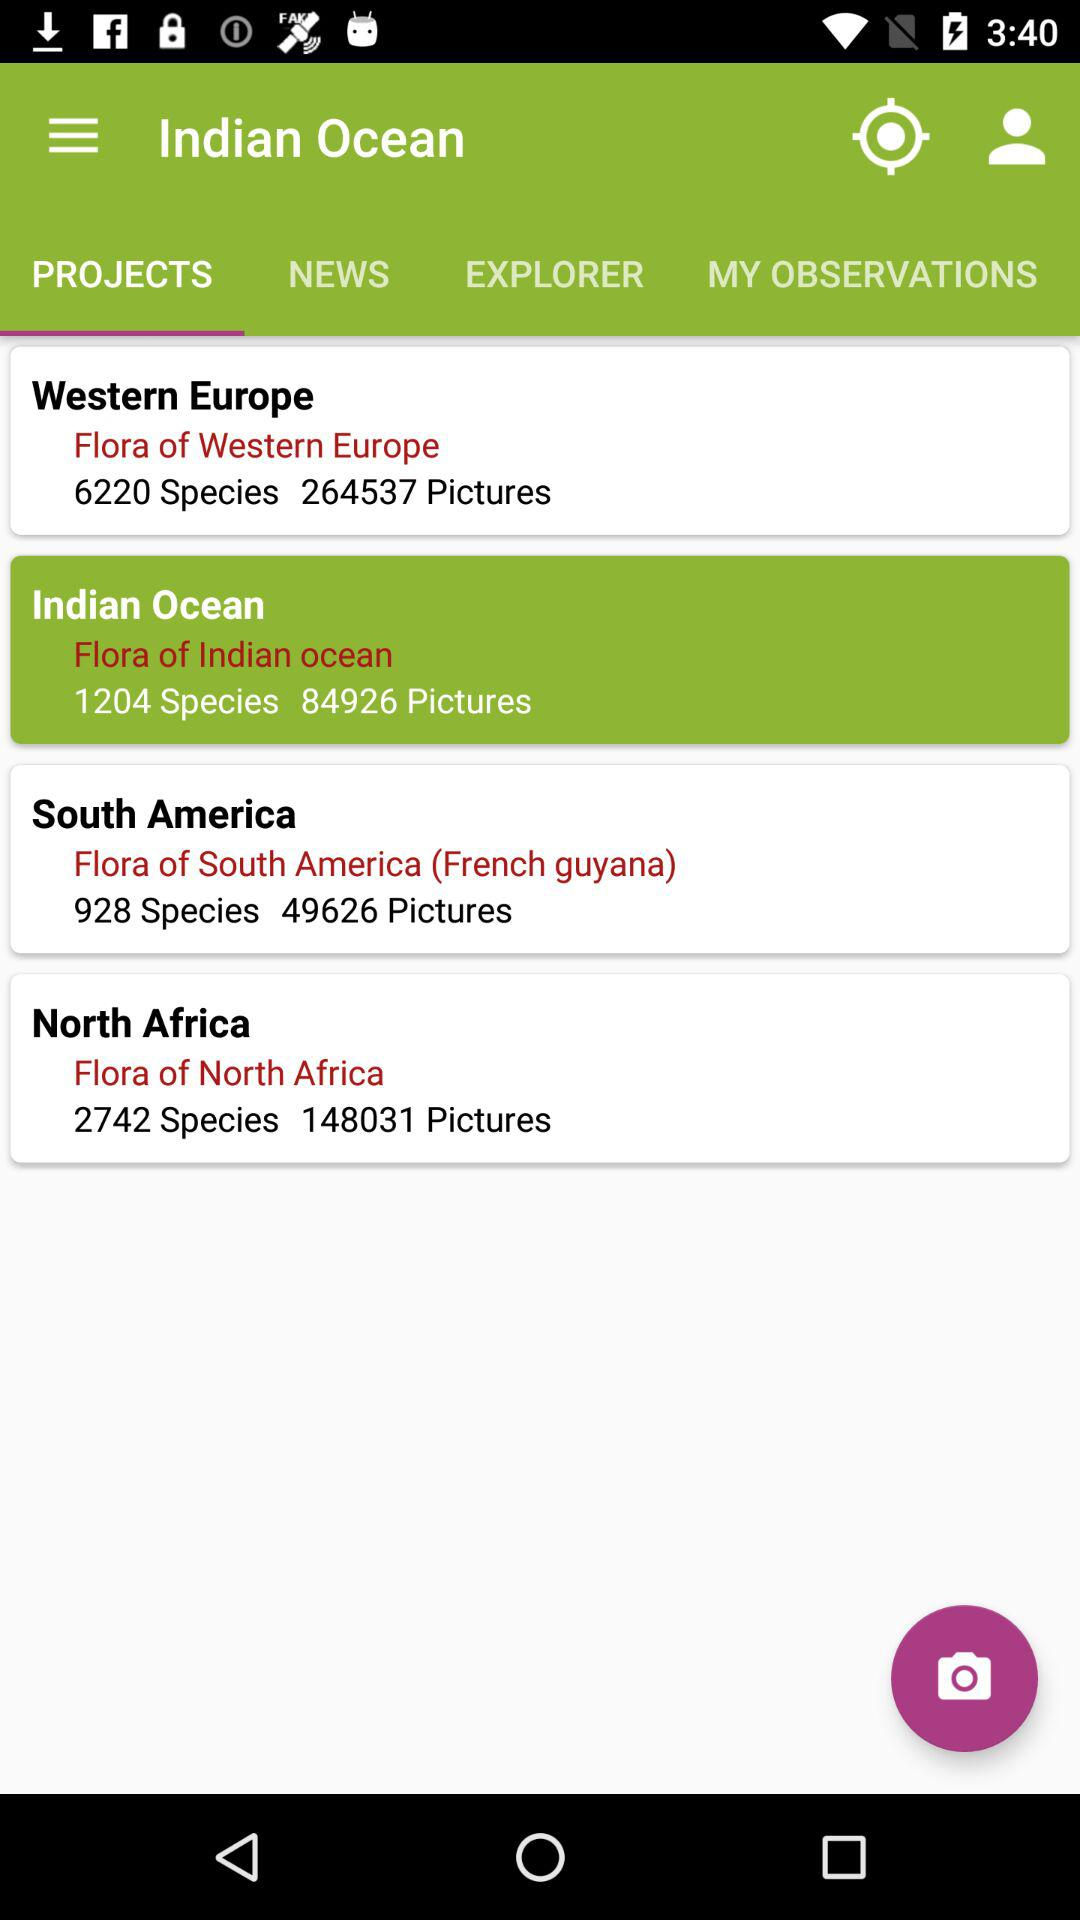Which option is selected in "Indian Ocean"? The selected option is "PROJECTS". 